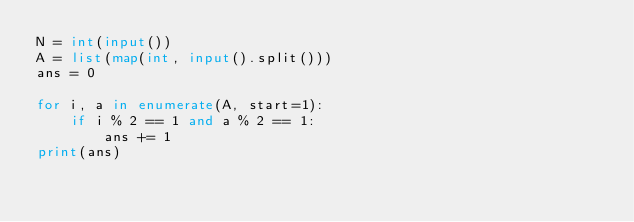<code> <loc_0><loc_0><loc_500><loc_500><_Python_>N = int(input())
A = list(map(int, input().split()))
ans = 0

for i, a in enumerate(A, start=1):
    if i % 2 == 1 and a % 2 == 1:
        ans += 1
print(ans)
</code> 